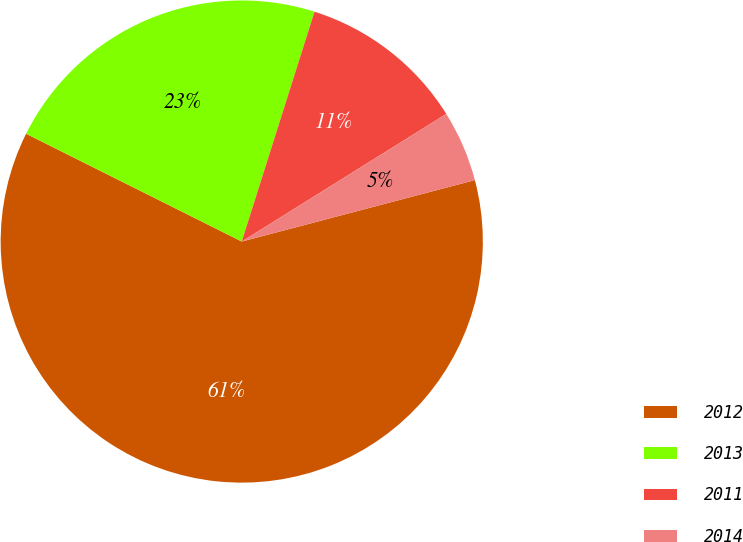<chart> <loc_0><loc_0><loc_500><loc_500><pie_chart><fcel>2012<fcel>2013<fcel>2011<fcel>2014<nl><fcel>61.48%<fcel>22.5%<fcel>11.24%<fcel>4.78%<nl></chart> 